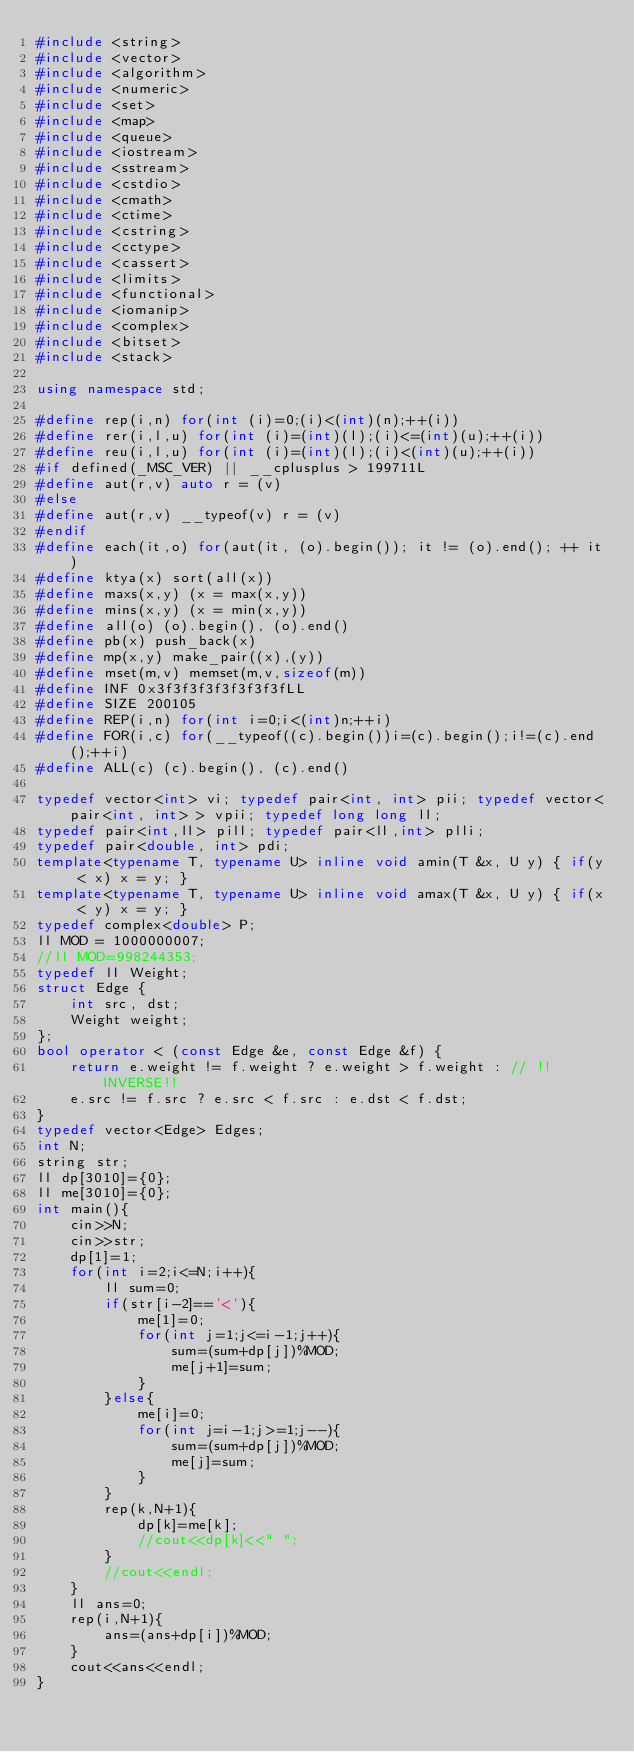Convert code to text. <code><loc_0><loc_0><loc_500><loc_500><_C++_>#include <string>
#include <vector>
#include <algorithm>
#include <numeric>
#include <set>
#include <map>
#include <queue>
#include <iostream>
#include <sstream>
#include <cstdio>
#include <cmath>
#include <ctime>
#include <cstring>
#include <cctype>
#include <cassert>
#include <limits>
#include <functional>
#include <iomanip>
#include <complex>
#include <bitset>
#include <stack>
 
using namespace std;
 
#define rep(i,n) for(int (i)=0;(i)<(int)(n);++(i))
#define rer(i,l,u) for(int (i)=(int)(l);(i)<=(int)(u);++(i))
#define reu(i,l,u) for(int (i)=(int)(l);(i)<(int)(u);++(i))
#if defined(_MSC_VER) || __cplusplus > 199711L
#define aut(r,v) auto r = (v)
#else
#define aut(r,v) __typeof(v) r = (v)
#endif
#define each(it,o) for(aut(it, (o).begin()); it != (o).end(); ++ it)
#define ktya(x) sort(all(x))
#define maxs(x,y) (x = max(x,y))
#define mins(x,y) (x = min(x,y))
#define all(o) (o).begin(), (o).end()
#define pb(x) push_back(x)
#define mp(x,y) make_pair((x),(y))
#define mset(m,v) memset(m,v,sizeof(m))
#define INF 0x3f3f3f3f3f3f3f3fLL
#define SIZE 200105
#define REP(i,n) for(int i=0;i<(int)n;++i)
#define FOR(i,c) for(__typeof((c).begin())i=(c).begin();i!=(c).end();++i)
#define ALL(c) (c).begin(), (c).end()
 
typedef vector<int> vi; typedef pair<int, int> pii; typedef vector<pair<int, int> > vpii; typedef long long ll;
typedef pair<int,ll> pill; typedef pair<ll,int> plli; 
typedef pair<double, int> pdi;
template<typename T, typename U> inline void amin(T &x, U y) { if(y < x) x = y; }
template<typename T, typename U> inline void amax(T &x, U y) { if(x < y) x = y; }
typedef complex<double> P;
ll MOD = 1000000007;
//ll MOD=998244353;
typedef ll Weight;
struct Edge {
	int src, dst;
	Weight weight;
};
bool operator < (const Edge &e, const Edge &f) {
	return e.weight != f.weight ? e.weight > f.weight : // !!INVERSE!!
	e.src != f.src ? e.src < f.src : e.dst < f.dst;
}
typedef vector<Edge> Edges;
int N;
string str;
ll dp[3010]={0};
ll me[3010]={0};
int main(){
	cin>>N;
	cin>>str;
	dp[1]=1;
	for(int i=2;i<=N;i++){
		ll sum=0;
		if(str[i-2]=='<'){
			me[1]=0;
			for(int j=1;j<=i-1;j++){
				sum=(sum+dp[j])%MOD;
				me[j+1]=sum;
			}
		}else{
			me[i]=0;
			for(int j=i-1;j>=1;j--){
				sum=(sum+dp[j])%MOD;
				me[j]=sum;
			}
		}
		rep(k,N+1){
			dp[k]=me[k];
			//cout<<dp[k]<<" ";
		}
		//cout<<endl;
	}
	ll ans=0;
	rep(i,N+1){
		ans=(ans+dp[i])%MOD;
	}
	cout<<ans<<endl;
}</code> 